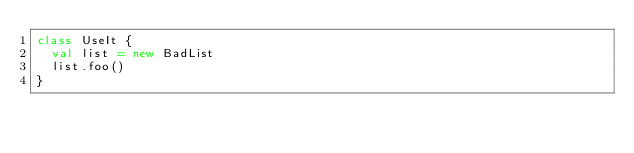Convert code to text. <code><loc_0><loc_0><loc_500><loc_500><_Scala_>class UseIt {
  val list = new BadList
  list.foo()
}
</code> 